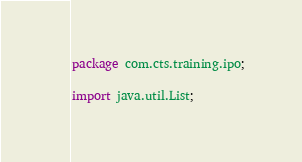<code> <loc_0><loc_0><loc_500><loc_500><_Java_>package com.cts.training.ipo;

import java.util.List;
</code> 